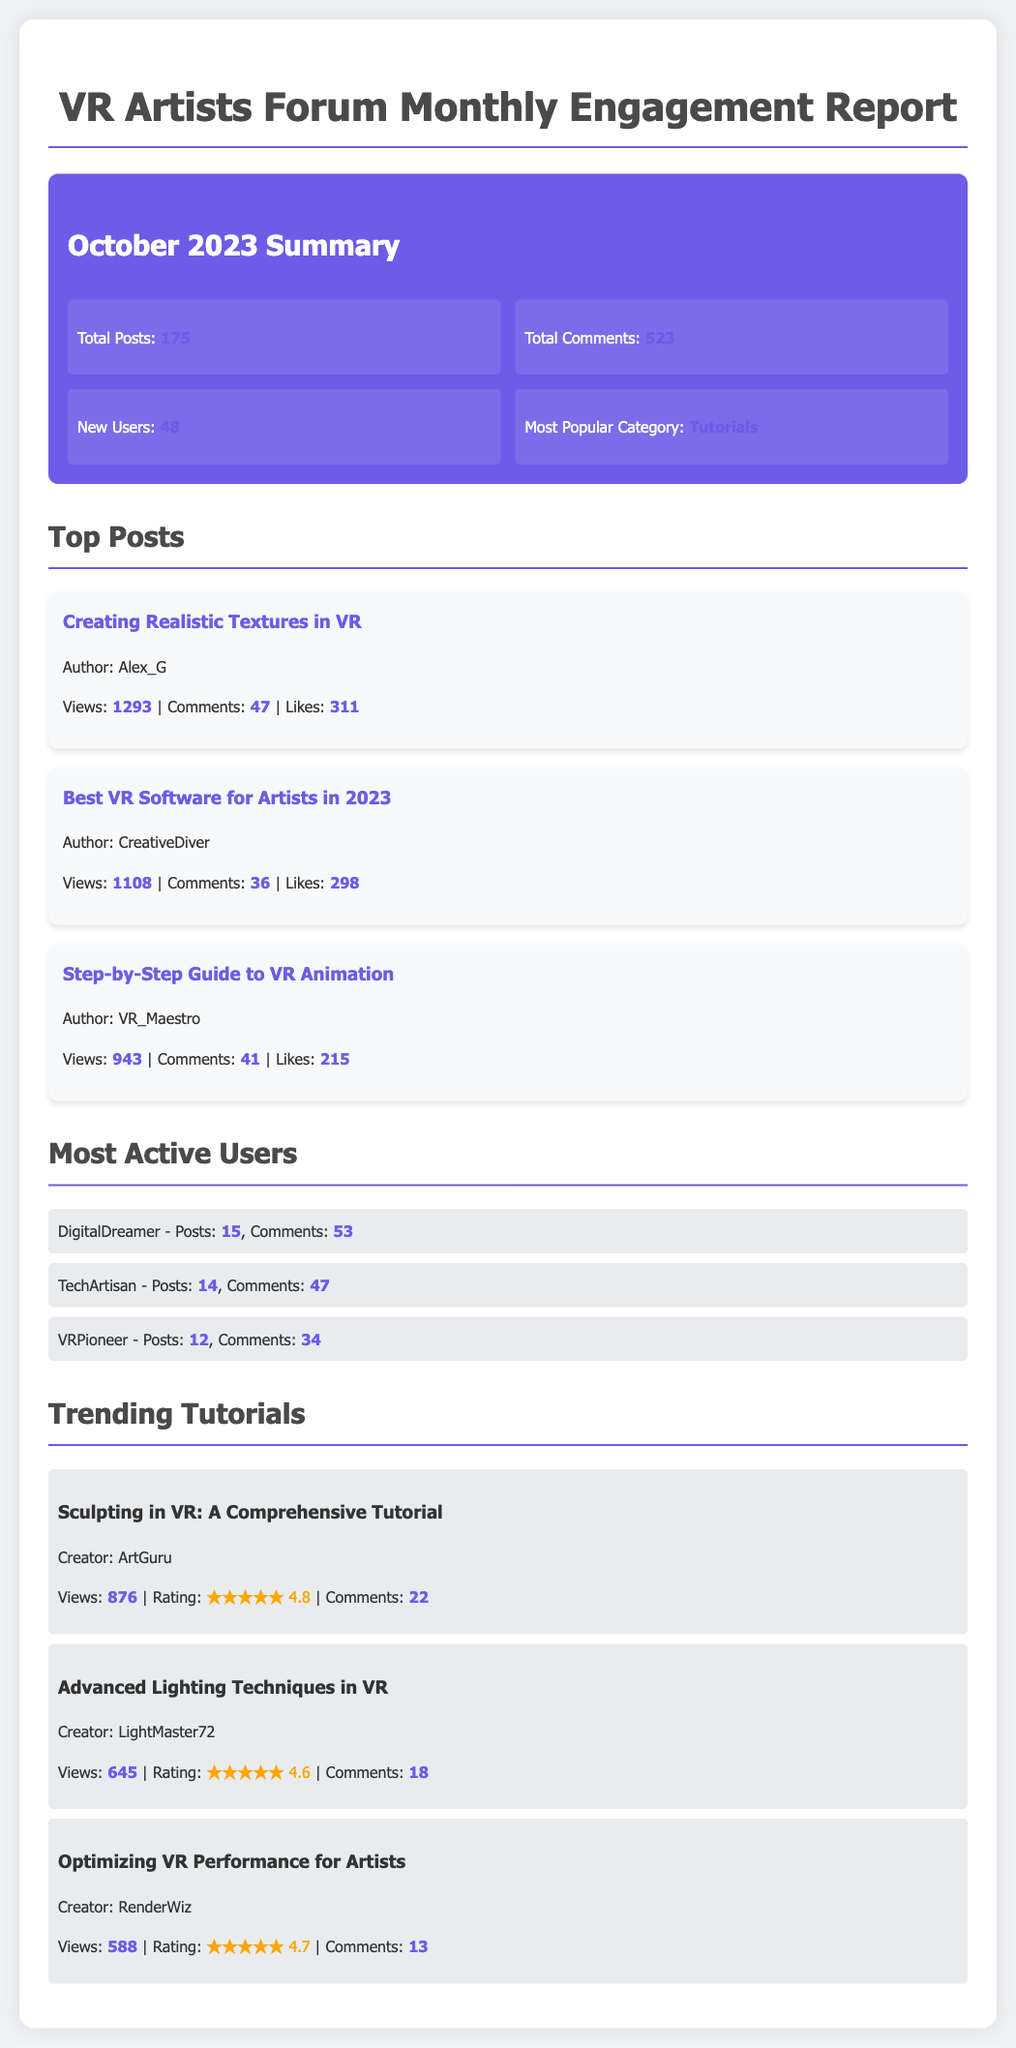What is the total number of posts in October 2023? The total number of posts is stated in the summary section of the document.
Answer: 175 Who is the author of the post titled "Creating Realistic Textures in VR"? The author's name is provided beneath the title of the post.
Answer: Alex_G What is the most popular category in October 2023? The popular category is indicated in the summary section.
Answer: Tutorials How many comments did the tutorial "Sculpting in VR: A Comprehensive Tutorial" receive? The number of comments for this tutorial is mentioned beside it in the list of trending tutorials.
Answer: 22 Which user posted the highest number of comments? The user with the most comments is listed first among the most active users.
Answer: DigitalDreamer What is the average rating for the tutorial "Advanced Lighting Techniques in VR"? The rating can be found next to the title of the tutorial.
Answer: 4.6 How many new users joined in October 2023? The number of new users is listed in the summary section.
Answer: 48 Which post has the highest number of views? The views are mentioned next to each post, allowing for comparison to determine the highest.
Answer: Creating Realistic Textures in VR How many total comments were made in October 2023? The total comments are provided in the summary section of the report.
Answer: 523 